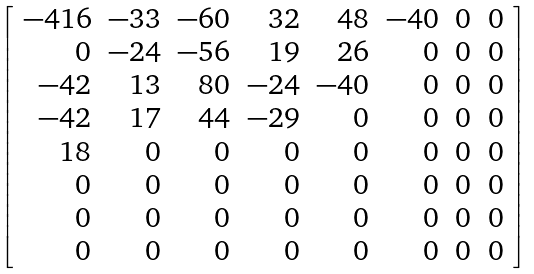<formula> <loc_0><loc_0><loc_500><loc_500>\left [ { \begin{array} { r r r r r r r r } { - 4 1 6 } & { - 3 3 } & { - 6 0 } & { 3 2 } & { 4 8 } & { - 4 0 } & { 0 } & { 0 } \\ { 0 } & { - 2 4 } & { - 5 6 } & { 1 9 } & { 2 6 } & { 0 } & { 0 } & { 0 } \\ { - 4 2 } & { 1 3 } & { 8 0 } & { - 2 4 } & { - 4 0 } & { 0 } & { 0 } & { 0 } \\ { - 4 2 } & { 1 7 } & { 4 4 } & { - 2 9 } & { 0 } & { 0 } & { 0 } & { 0 } \\ { 1 8 } & { 0 } & { 0 } & { 0 } & { 0 } & { 0 } & { 0 } & { 0 } \\ { 0 } & { 0 } & { 0 } & { 0 } & { 0 } & { 0 } & { 0 } & { 0 } \\ { 0 } & { 0 } & { 0 } & { 0 } & { 0 } & { 0 } & { 0 } & { 0 } \\ { 0 } & { 0 } & { 0 } & { 0 } & { 0 } & { 0 } & { 0 } & { 0 } \end{array} } \right ]</formula> 